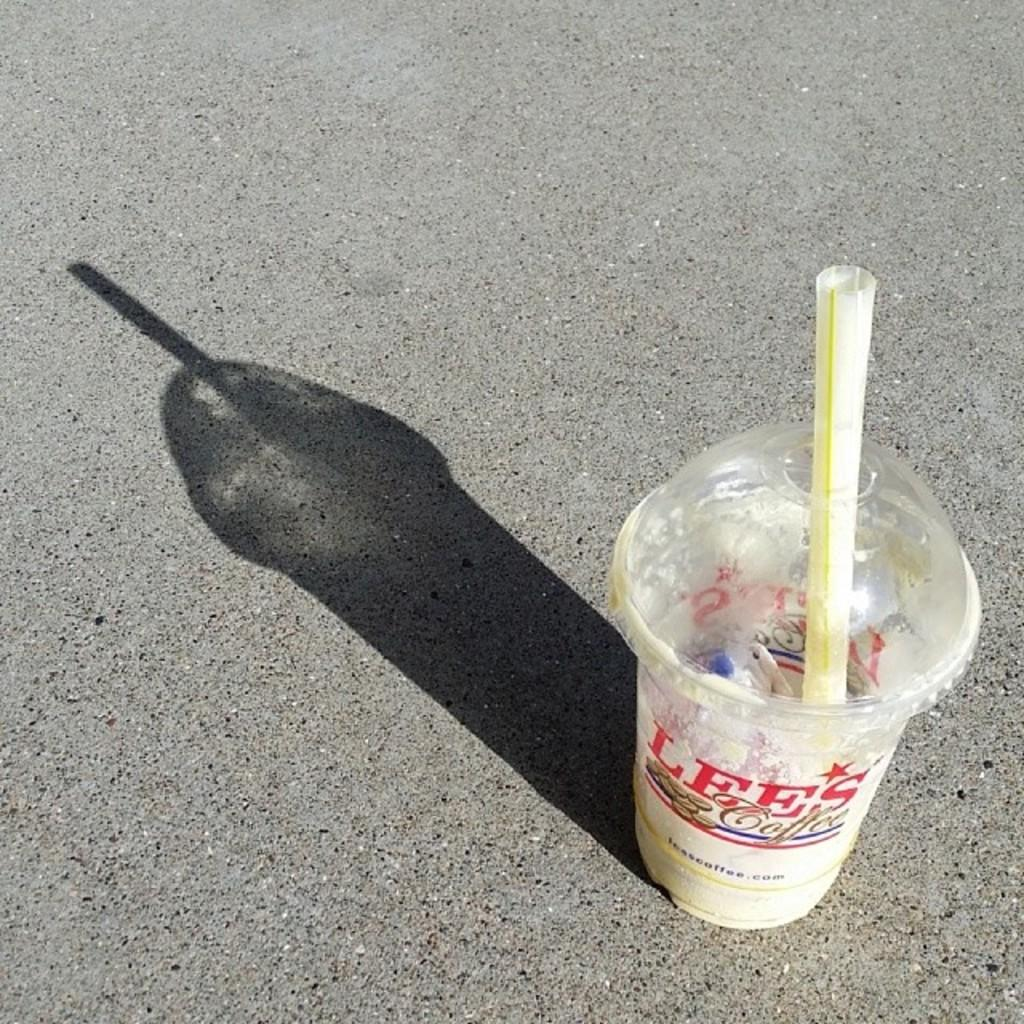What type of container is visible in the image? There is a disposable tumbler in the image. What is inside the disposable tumbler? The disposable tumbler has a straw in it. Where is the disposable tumbler located in the image? The disposable tumbler is placed on the floor. What type of drain is visible in the image? There is no drain present in the image. 